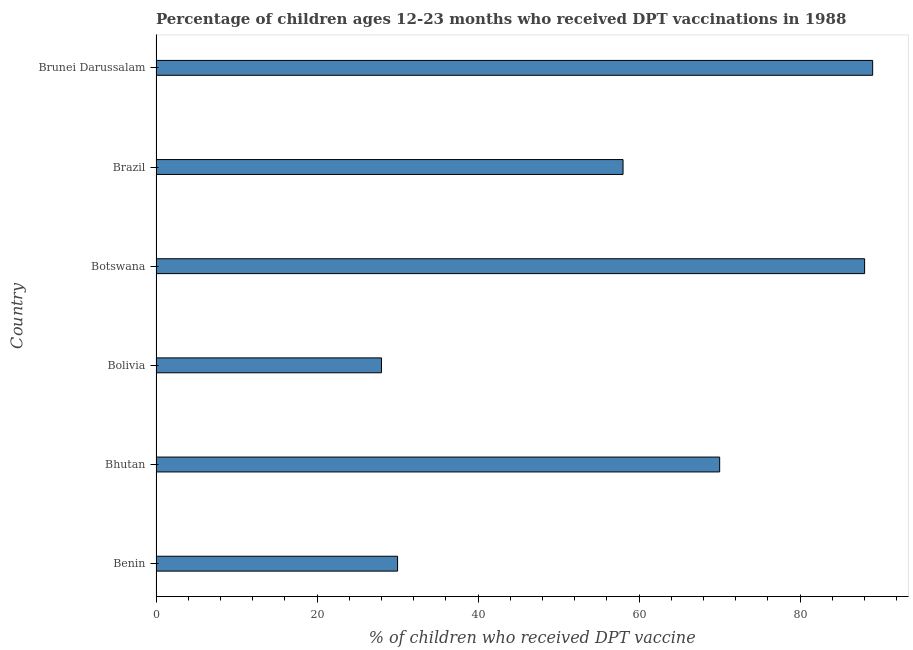Does the graph contain grids?
Provide a short and direct response. No. What is the title of the graph?
Keep it short and to the point. Percentage of children ages 12-23 months who received DPT vaccinations in 1988. What is the label or title of the X-axis?
Your answer should be compact. % of children who received DPT vaccine. What is the label or title of the Y-axis?
Your answer should be compact. Country. What is the percentage of children who received dpt vaccine in Brunei Darussalam?
Provide a short and direct response. 89. Across all countries, what is the maximum percentage of children who received dpt vaccine?
Your answer should be compact. 89. In which country was the percentage of children who received dpt vaccine maximum?
Provide a succinct answer. Brunei Darussalam. What is the sum of the percentage of children who received dpt vaccine?
Your answer should be very brief. 363. What is the difference between the percentage of children who received dpt vaccine in Botswana and Brazil?
Your response must be concise. 30. What is the average percentage of children who received dpt vaccine per country?
Ensure brevity in your answer.  60.5. What is the median percentage of children who received dpt vaccine?
Provide a succinct answer. 64. In how many countries, is the percentage of children who received dpt vaccine greater than 80 %?
Keep it short and to the point. 2. What is the ratio of the percentage of children who received dpt vaccine in Benin to that in Brunei Darussalam?
Offer a terse response. 0.34. Is the percentage of children who received dpt vaccine in Bolivia less than that in Brunei Darussalam?
Provide a short and direct response. Yes. Is the difference between the percentage of children who received dpt vaccine in Benin and Brazil greater than the difference between any two countries?
Provide a succinct answer. No. Is the sum of the percentage of children who received dpt vaccine in Benin and Bhutan greater than the maximum percentage of children who received dpt vaccine across all countries?
Provide a succinct answer. Yes. In how many countries, is the percentage of children who received dpt vaccine greater than the average percentage of children who received dpt vaccine taken over all countries?
Give a very brief answer. 3. Are all the bars in the graph horizontal?
Your answer should be compact. Yes. What is the difference between two consecutive major ticks on the X-axis?
Offer a very short reply. 20. Are the values on the major ticks of X-axis written in scientific E-notation?
Ensure brevity in your answer.  No. What is the % of children who received DPT vaccine of Bhutan?
Give a very brief answer. 70. What is the % of children who received DPT vaccine in Botswana?
Your answer should be compact. 88. What is the % of children who received DPT vaccine in Brazil?
Provide a short and direct response. 58. What is the % of children who received DPT vaccine of Brunei Darussalam?
Your response must be concise. 89. What is the difference between the % of children who received DPT vaccine in Benin and Botswana?
Your answer should be very brief. -58. What is the difference between the % of children who received DPT vaccine in Benin and Brazil?
Your response must be concise. -28. What is the difference between the % of children who received DPT vaccine in Benin and Brunei Darussalam?
Keep it short and to the point. -59. What is the difference between the % of children who received DPT vaccine in Bhutan and Bolivia?
Provide a short and direct response. 42. What is the difference between the % of children who received DPT vaccine in Bhutan and Brunei Darussalam?
Make the answer very short. -19. What is the difference between the % of children who received DPT vaccine in Bolivia and Botswana?
Offer a very short reply. -60. What is the difference between the % of children who received DPT vaccine in Bolivia and Brunei Darussalam?
Offer a terse response. -61. What is the difference between the % of children who received DPT vaccine in Botswana and Brazil?
Ensure brevity in your answer.  30. What is the difference between the % of children who received DPT vaccine in Botswana and Brunei Darussalam?
Give a very brief answer. -1. What is the difference between the % of children who received DPT vaccine in Brazil and Brunei Darussalam?
Make the answer very short. -31. What is the ratio of the % of children who received DPT vaccine in Benin to that in Bhutan?
Ensure brevity in your answer.  0.43. What is the ratio of the % of children who received DPT vaccine in Benin to that in Bolivia?
Make the answer very short. 1.07. What is the ratio of the % of children who received DPT vaccine in Benin to that in Botswana?
Your answer should be very brief. 0.34. What is the ratio of the % of children who received DPT vaccine in Benin to that in Brazil?
Offer a very short reply. 0.52. What is the ratio of the % of children who received DPT vaccine in Benin to that in Brunei Darussalam?
Your response must be concise. 0.34. What is the ratio of the % of children who received DPT vaccine in Bhutan to that in Bolivia?
Your response must be concise. 2.5. What is the ratio of the % of children who received DPT vaccine in Bhutan to that in Botswana?
Your answer should be compact. 0.8. What is the ratio of the % of children who received DPT vaccine in Bhutan to that in Brazil?
Ensure brevity in your answer.  1.21. What is the ratio of the % of children who received DPT vaccine in Bhutan to that in Brunei Darussalam?
Make the answer very short. 0.79. What is the ratio of the % of children who received DPT vaccine in Bolivia to that in Botswana?
Offer a terse response. 0.32. What is the ratio of the % of children who received DPT vaccine in Bolivia to that in Brazil?
Provide a short and direct response. 0.48. What is the ratio of the % of children who received DPT vaccine in Bolivia to that in Brunei Darussalam?
Offer a terse response. 0.32. What is the ratio of the % of children who received DPT vaccine in Botswana to that in Brazil?
Provide a short and direct response. 1.52. What is the ratio of the % of children who received DPT vaccine in Botswana to that in Brunei Darussalam?
Your response must be concise. 0.99. What is the ratio of the % of children who received DPT vaccine in Brazil to that in Brunei Darussalam?
Provide a succinct answer. 0.65. 